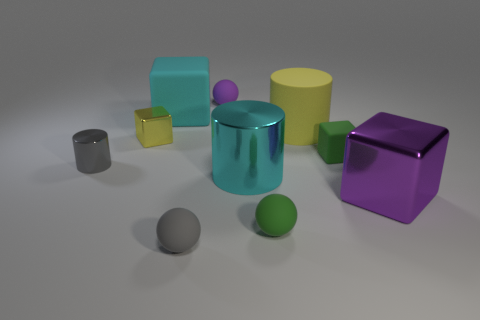There is a matte object that is both behind the tiny matte block and to the right of the small green ball; how big is it?
Ensure brevity in your answer.  Large. Do the green ball and the cyan block have the same size?
Make the answer very short. No. Do the big cube that is in front of the big cyan block and the large shiny cylinder have the same color?
Your answer should be compact. No. There is a gray matte ball; what number of rubber objects are in front of it?
Your response must be concise. 0. Is the number of tiny yellow shiny objects greater than the number of green metal cylinders?
Keep it short and to the point. Yes. The tiny object that is in front of the yellow rubber object and behind the tiny rubber block has what shape?
Offer a terse response. Cube. Are there any big matte cubes?
Offer a terse response. Yes. What is the material of the green thing that is the same shape as the large purple shiny thing?
Your answer should be compact. Rubber. What is the shape of the small gray object left of the ball that is to the left of the purple object on the left side of the large metallic block?
Your answer should be compact. Cylinder. There is a small object that is the same color as the tiny cylinder; what is its material?
Your answer should be very brief. Rubber. 